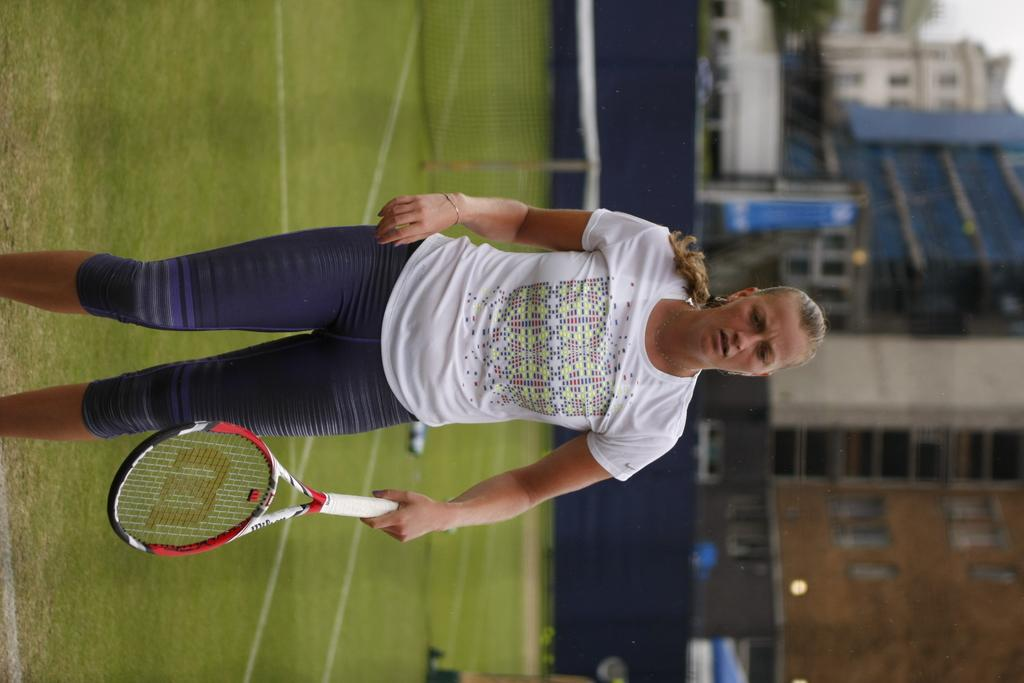Who is present in the image? There is a woman in the image. What is the woman doing in the image? The woman is standing and holding a tennis racket in her hand. What can be seen in the background of the image? There is a net, buildings, a tree, and the sky visible in the background of the image. What type of badge is the woman wearing on her side in the image? There is no badge visible on the woman's side in the image. 